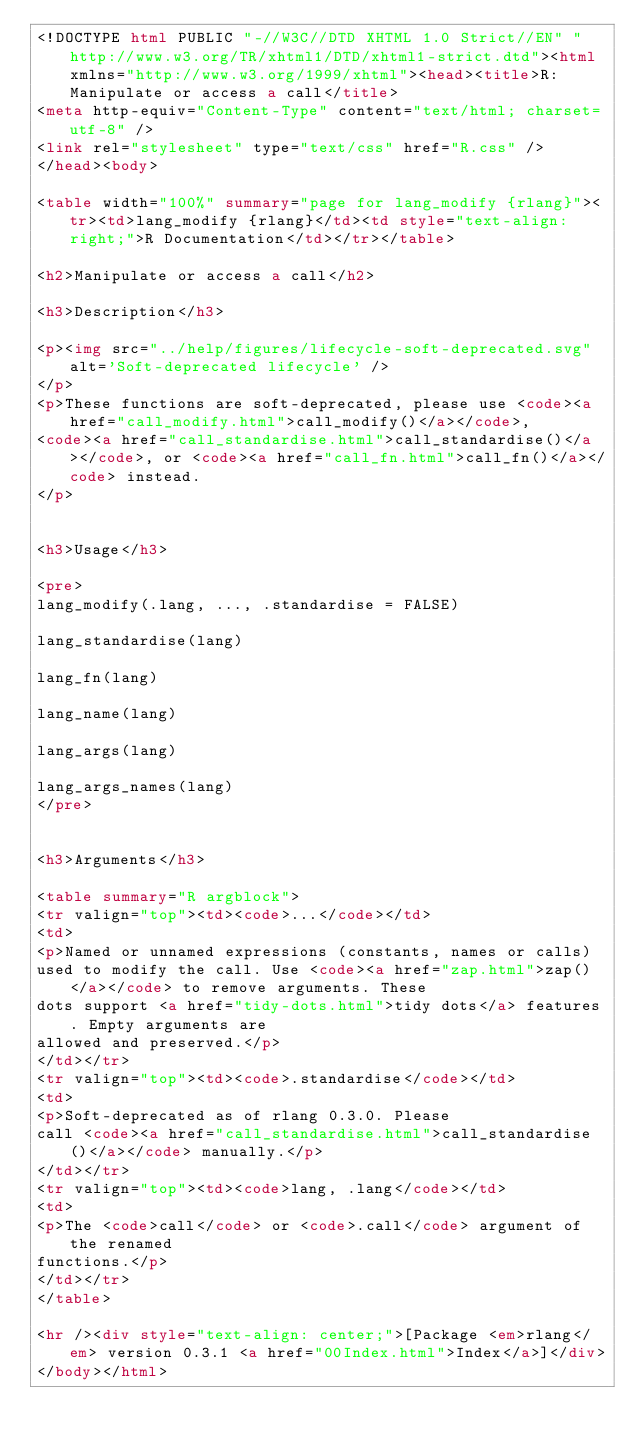<code> <loc_0><loc_0><loc_500><loc_500><_HTML_><!DOCTYPE html PUBLIC "-//W3C//DTD XHTML 1.0 Strict//EN" "http://www.w3.org/TR/xhtml1/DTD/xhtml1-strict.dtd"><html xmlns="http://www.w3.org/1999/xhtml"><head><title>R: Manipulate or access a call</title>
<meta http-equiv="Content-Type" content="text/html; charset=utf-8" />
<link rel="stylesheet" type="text/css" href="R.css" />
</head><body>

<table width="100%" summary="page for lang_modify {rlang}"><tr><td>lang_modify {rlang}</td><td style="text-align: right;">R Documentation</td></tr></table>

<h2>Manipulate or access a call</h2>

<h3>Description</h3>

<p><img src="../help/figures/lifecycle-soft-deprecated.svg" alt='Soft-deprecated lifecycle' />
</p>
<p>These functions are soft-deprecated, please use <code><a href="call_modify.html">call_modify()</a></code>,
<code><a href="call_standardise.html">call_standardise()</a></code>, or <code><a href="call_fn.html">call_fn()</a></code> instead.
</p>


<h3>Usage</h3>

<pre>
lang_modify(.lang, ..., .standardise = FALSE)

lang_standardise(lang)

lang_fn(lang)

lang_name(lang)

lang_args(lang)

lang_args_names(lang)
</pre>


<h3>Arguments</h3>

<table summary="R argblock">
<tr valign="top"><td><code>...</code></td>
<td>
<p>Named or unnamed expressions (constants, names or calls)
used to modify the call. Use <code><a href="zap.html">zap()</a></code> to remove arguments. These
dots support <a href="tidy-dots.html">tidy dots</a> features. Empty arguments are
allowed and preserved.</p>
</td></tr>
<tr valign="top"><td><code>.standardise</code></td>
<td>
<p>Soft-deprecated as of rlang 0.3.0. Please
call <code><a href="call_standardise.html">call_standardise()</a></code> manually.</p>
</td></tr>
<tr valign="top"><td><code>lang, .lang</code></td>
<td>
<p>The <code>call</code> or <code>.call</code> argument of the renamed
functions.</p>
</td></tr>
</table>

<hr /><div style="text-align: center;">[Package <em>rlang</em> version 0.3.1 <a href="00Index.html">Index</a>]</div>
</body></html>
</code> 